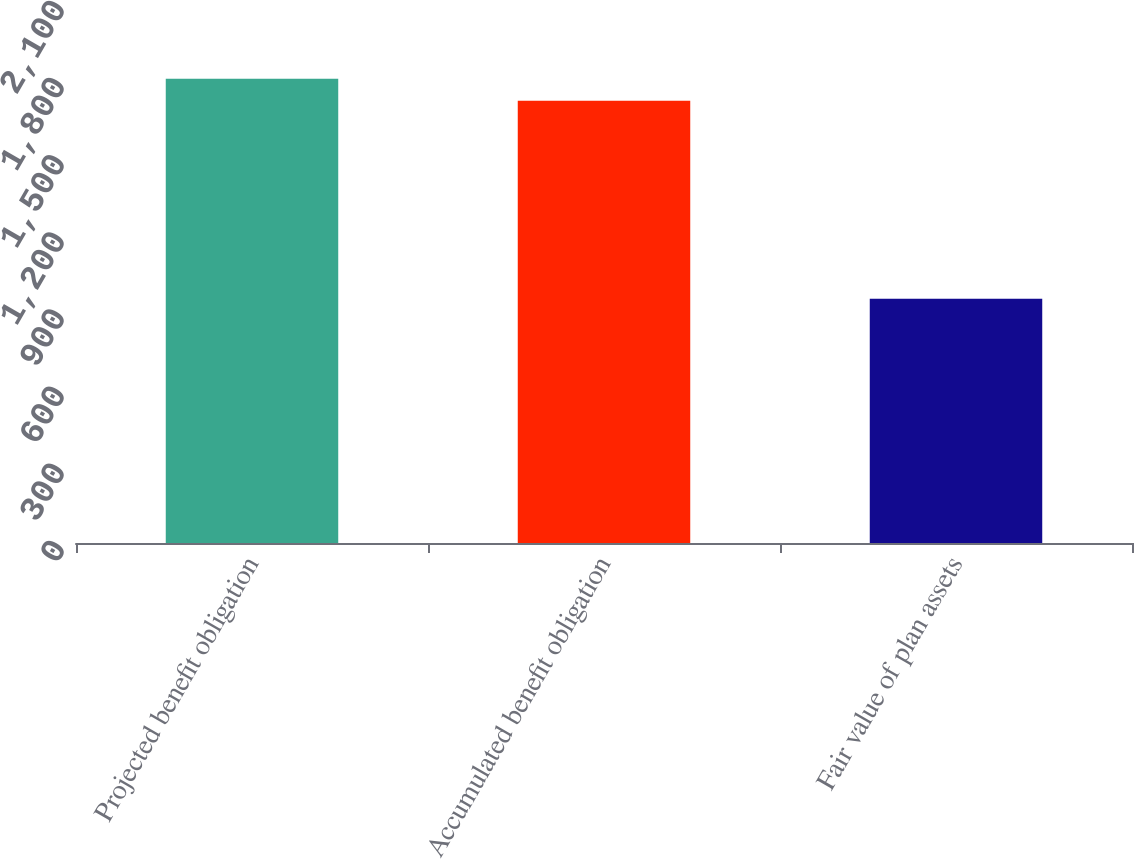Convert chart to OTSL. <chart><loc_0><loc_0><loc_500><loc_500><bar_chart><fcel>Projected benefit obligation<fcel>Accumulated benefit obligation<fcel>Fair value of plan assets<nl><fcel>1805.1<fcel>1720<fcel>950<nl></chart> 